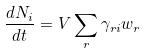<formula> <loc_0><loc_0><loc_500><loc_500>\frac { d N _ { i } } { d t } = V \sum _ { r } \gamma _ { r i } w _ { r }</formula> 